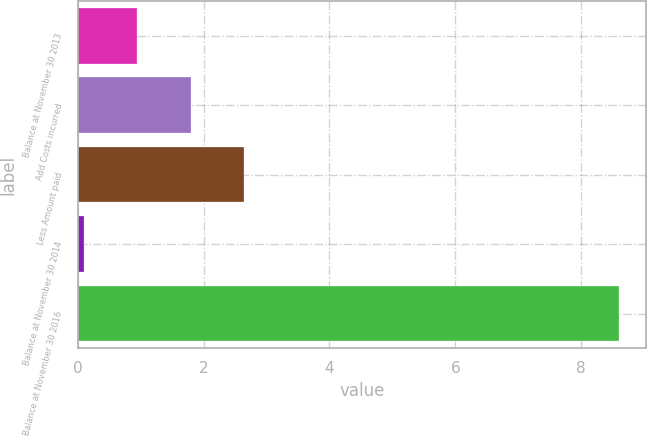Convert chart. <chart><loc_0><loc_0><loc_500><loc_500><bar_chart><fcel>Balance at November 30 2013<fcel>Add Costs incurred<fcel>Less Amount paid<fcel>Balance at November 30 2014<fcel>Balance at November 30 2016<nl><fcel>0.95<fcel>1.8<fcel>2.65<fcel>0.1<fcel>8.6<nl></chart> 